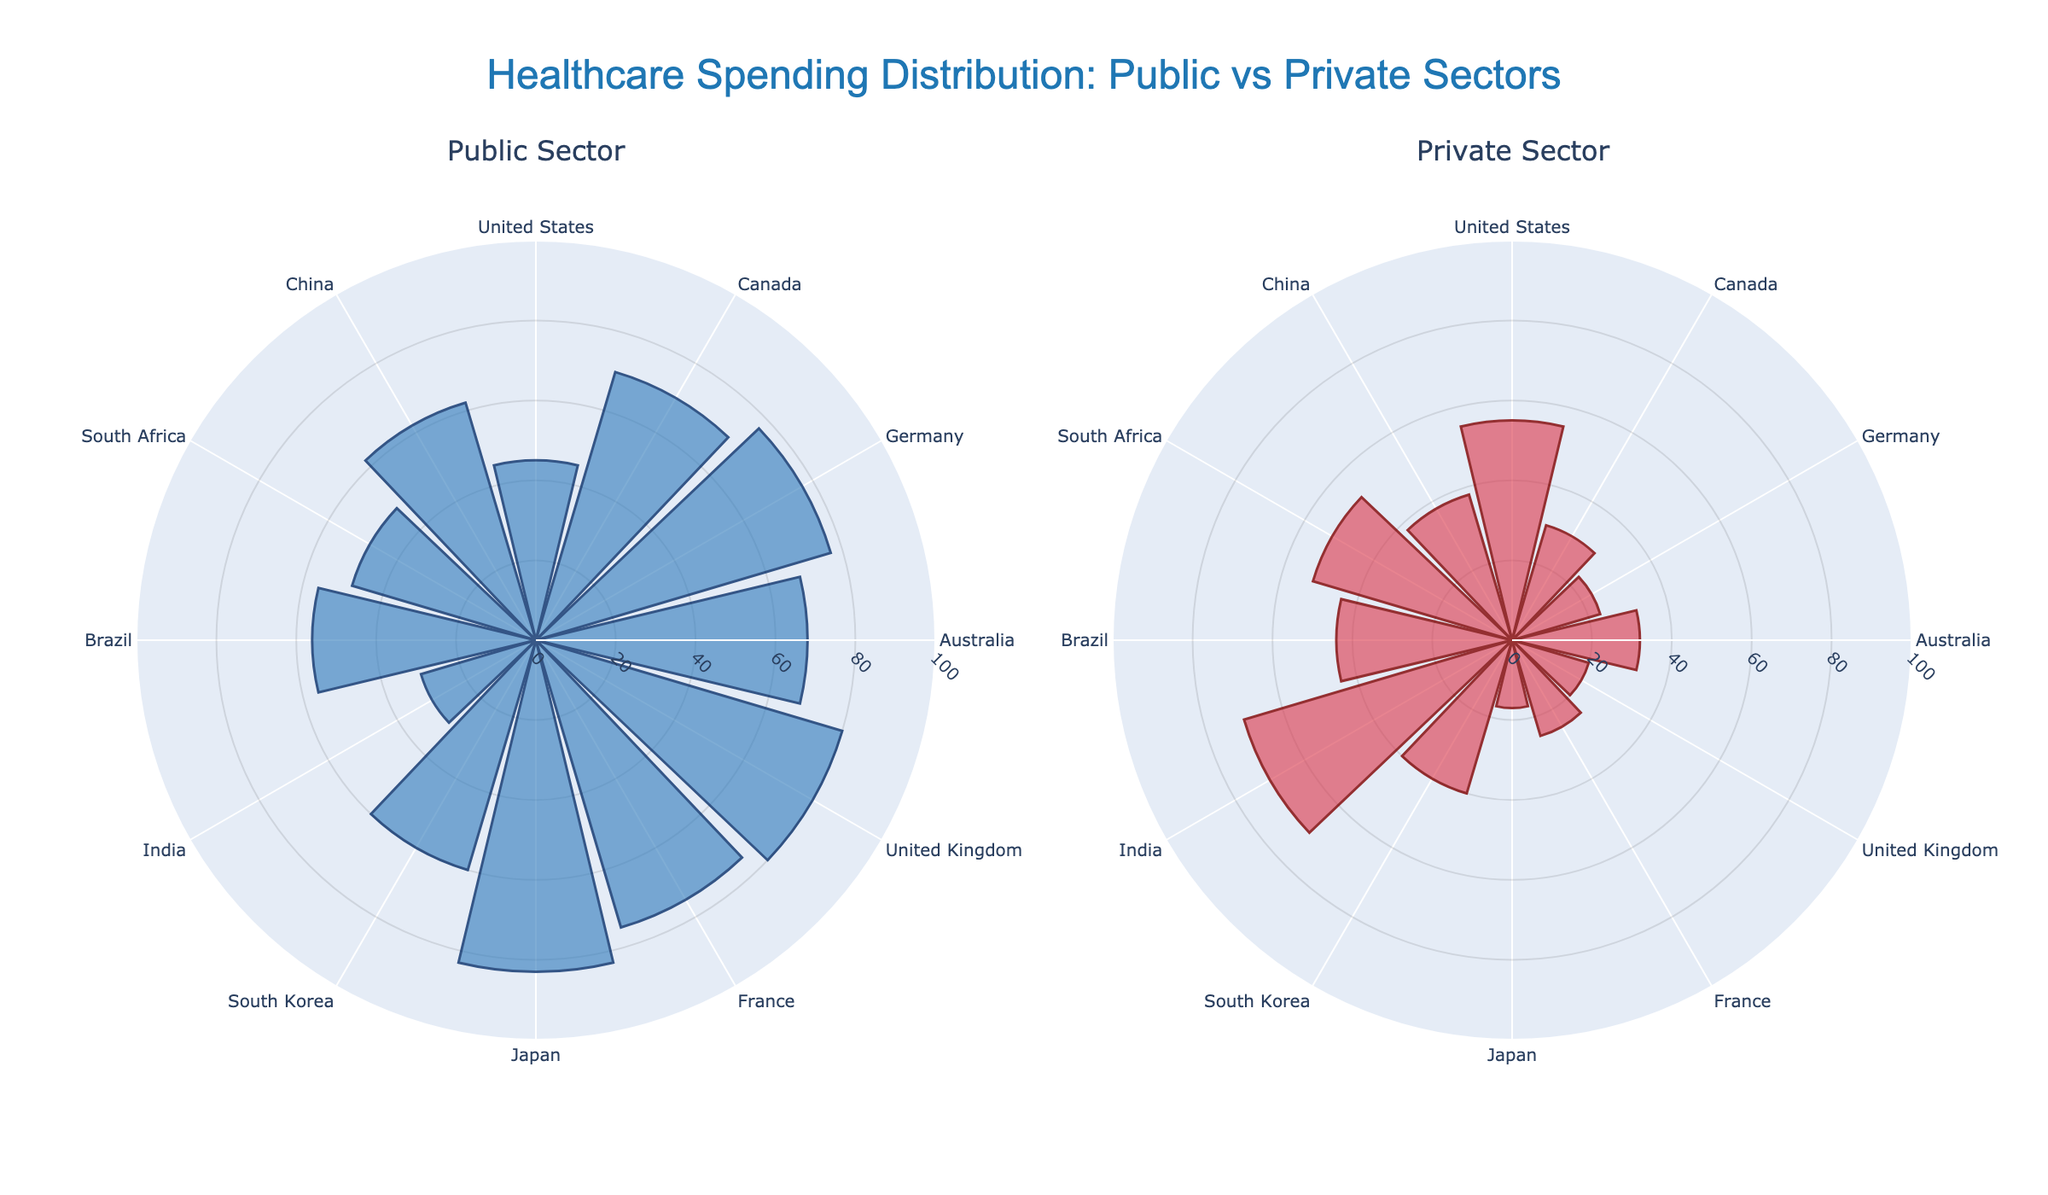What is the title of the figure? The title is displayed at the top of the figure and reads "Healthcare Spending Distribution: Public vs Private Sectors".
Answer: "Healthcare Spending Distribution: Public vs Private Sectors" Which country has the highest percentage of public sector healthcare spending? Look for the country with the tallest bar in the "Public Sector" subplot. Japan has the tallest bar at 83%.
Answer: Japan Which country has the highest percentage of private sector healthcare spending? Look for the country with the tallest bar in the "Private Sector" subplot. India has the tallest bar at 70%.
Answer: India How many countries are represented in the figure? Count the number of bars in either the public or private sector subplots. There are 12 bars, so there are 12 countries.
Answer: 12 What's the difference in public healthcare spending percentages between the United Kingdom and the United States? Find the bar heights for the United Kingdom (80%) and the United States (45%). Subtract the smaller percentage from the larger percentage: 80% - 45% = 35%.
Answer: 35% Which country has the closest balance between public and private healthcare spending? Compare the bar heights for each country in both subplots. The United States has the closest balance with public sector at 45% and private sector at 55%.
Answer: United States Calculate the average public sector healthcare spending across all countries. Add the public sector percentages for all countries and divide by the number of countries: (45 + 70 + 77 + 68 + 80 + 75 + 83 + 60 + 30 + 56 + 48 + 62) / 12 = 62.25%.
Answer: 62.25% Which country has a greater private sector spending compared to the public sector? Compare bar heights in the public and private sector subplots for each country. India has private (70%) greater than public (30%) spending.
Answer: India How does Germany's public sector spending compare to that of Australia? Find the bar heights for Germany and Australia in the public sector subplot. Germany has 77% and Australia has 68%. Germany's public sector spending is higher.
Answer: Germany's spending is higher 